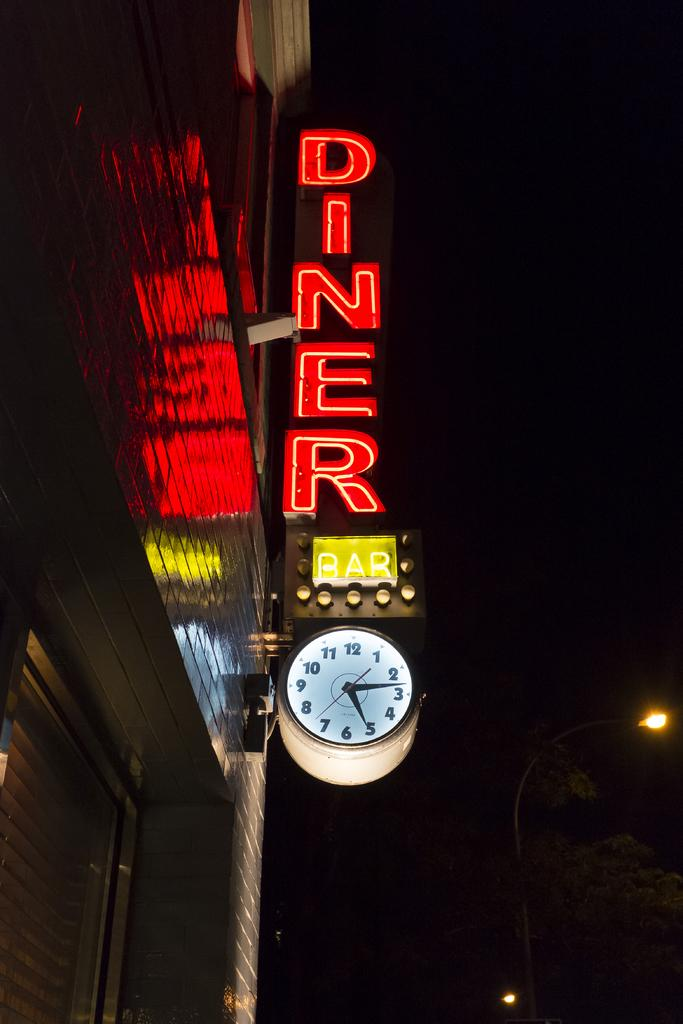<image>
Provide a brief description of the given image. A clock that's sitting beneath a bar sign reads five fourteen. 